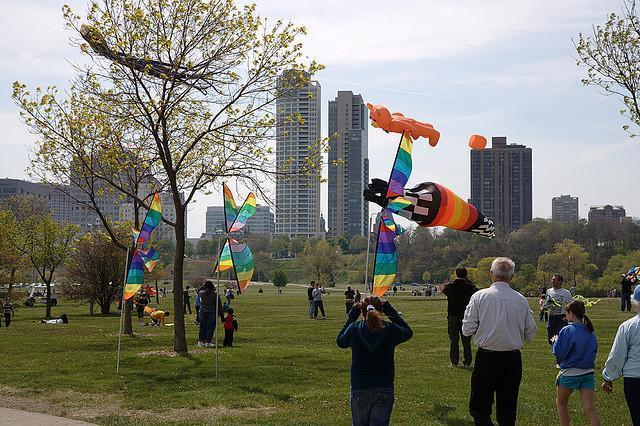How many people are laying on the grass?
Give a very brief answer. 1. How many people are in the picture?
Give a very brief answer. 5. 